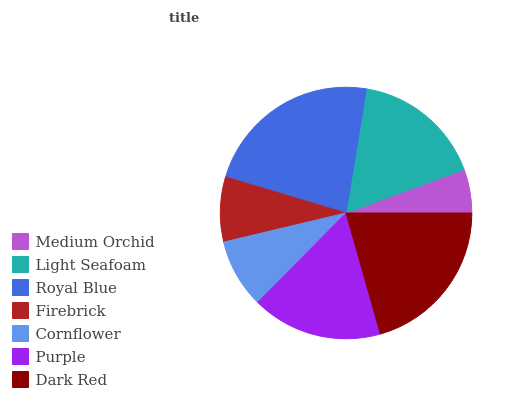Is Medium Orchid the minimum?
Answer yes or no. Yes. Is Royal Blue the maximum?
Answer yes or no. Yes. Is Light Seafoam the minimum?
Answer yes or no. No. Is Light Seafoam the maximum?
Answer yes or no. No. Is Light Seafoam greater than Medium Orchid?
Answer yes or no. Yes. Is Medium Orchid less than Light Seafoam?
Answer yes or no. Yes. Is Medium Orchid greater than Light Seafoam?
Answer yes or no. No. Is Light Seafoam less than Medium Orchid?
Answer yes or no. No. Is Light Seafoam the high median?
Answer yes or no. Yes. Is Light Seafoam the low median?
Answer yes or no. Yes. Is Cornflower the high median?
Answer yes or no. No. Is Dark Red the low median?
Answer yes or no. No. 